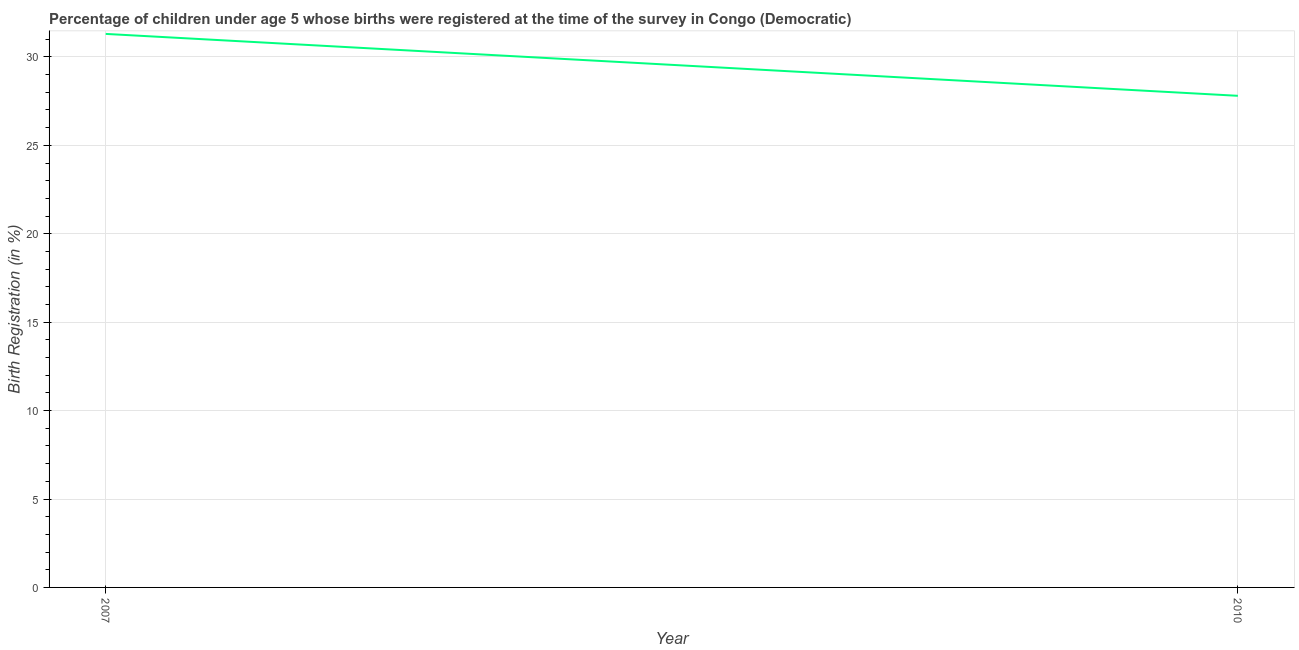What is the birth registration in 2007?
Your answer should be compact. 31.3. Across all years, what is the maximum birth registration?
Your answer should be very brief. 31.3. Across all years, what is the minimum birth registration?
Your response must be concise. 27.8. In which year was the birth registration maximum?
Ensure brevity in your answer.  2007. In which year was the birth registration minimum?
Ensure brevity in your answer.  2010. What is the sum of the birth registration?
Provide a succinct answer. 59.1. What is the difference between the birth registration in 2007 and 2010?
Give a very brief answer. 3.5. What is the average birth registration per year?
Provide a short and direct response. 29.55. What is the median birth registration?
Provide a short and direct response. 29.55. In how many years, is the birth registration greater than 6 %?
Your answer should be very brief. 2. What is the ratio of the birth registration in 2007 to that in 2010?
Provide a succinct answer. 1.13. In how many years, is the birth registration greater than the average birth registration taken over all years?
Your answer should be very brief. 1. How many lines are there?
Your answer should be very brief. 1. Are the values on the major ticks of Y-axis written in scientific E-notation?
Keep it short and to the point. No. What is the title of the graph?
Make the answer very short. Percentage of children under age 5 whose births were registered at the time of the survey in Congo (Democratic). What is the label or title of the X-axis?
Offer a very short reply. Year. What is the label or title of the Y-axis?
Your response must be concise. Birth Registration (in %). What is the Birth Registration (in %) of 2007?
Make the answer very short. 31.3. What is the Birth Registration (in %) of 2010?
Offer a terse response. 27.8. What is the difference between the Birth Registration (in %) in 2007 and 2010?
Provide a short and direct response. 3.5. What is the ratio of the Birth Registration (in %) in 2007 to that in 2010?
Provide a short and direct response. 1.13. 